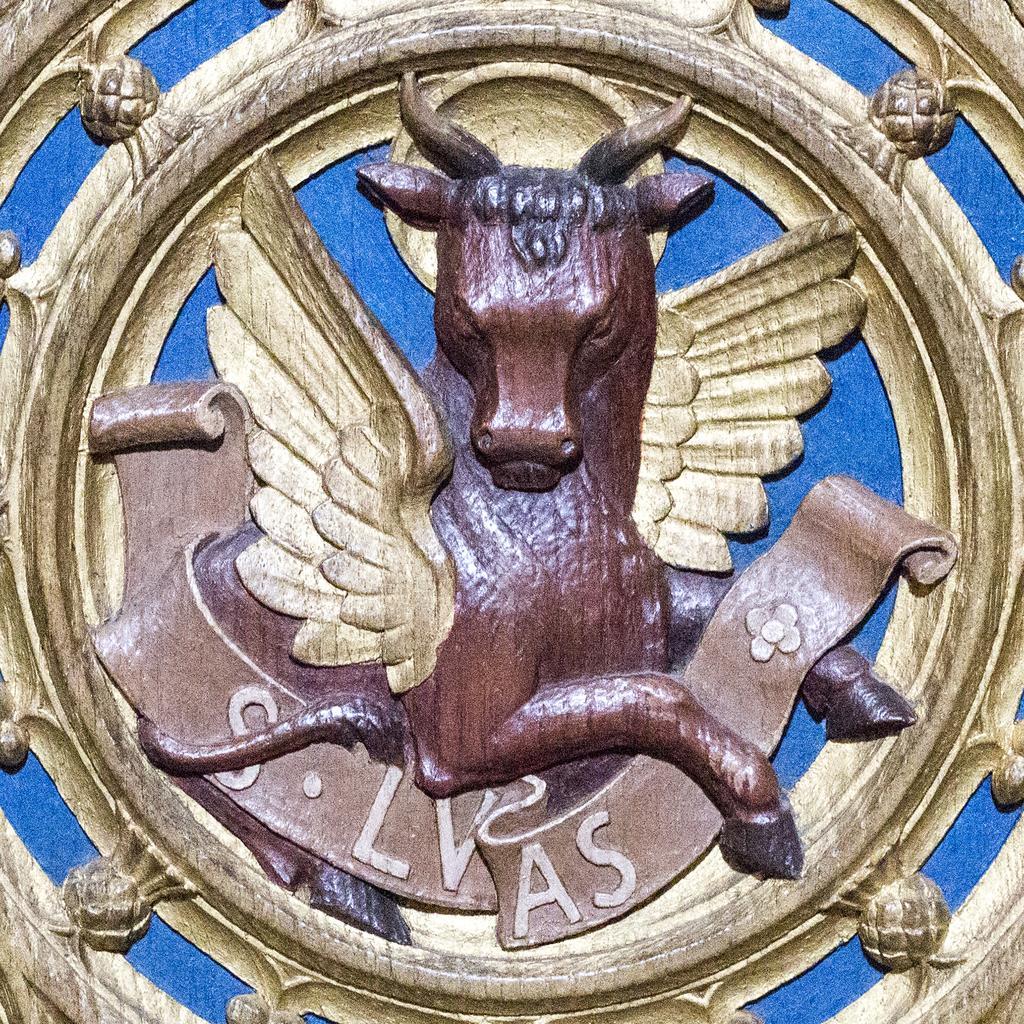Describe this image in one or two sentences. In this image I can see the logo. In the logo I can see an animal in brown color and the wings are in gold color and I can see the blue color background. 